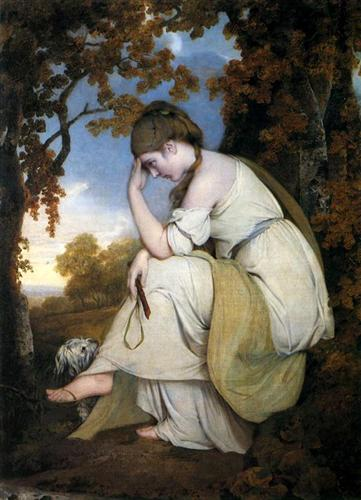What does the woman's expression tell us about her state of mind? The woman's contemplative pose, with her head resting on her hand, suggests she is deep in thought or experiencing a moment of introspection. Her downcast eyes and the serene yet slightly melancholic atmosphere imply that she might be reminiscing or reflecting on something personal or significant. 